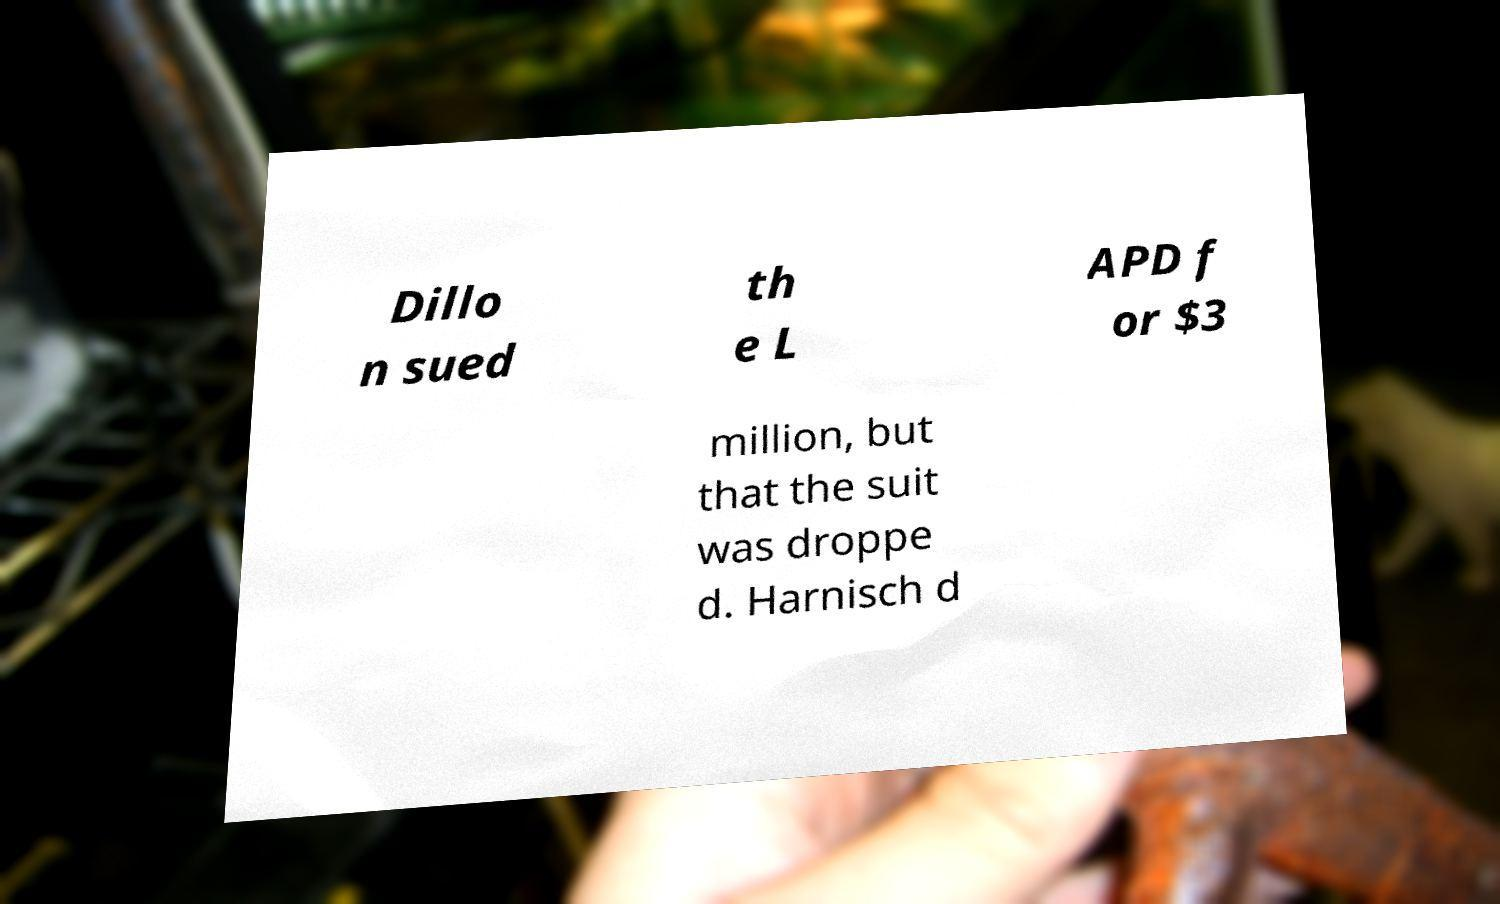Could you extract and type out the text from this image? Dillo n sued th e L APD f or $3 million, but that the suit was droppe d. Harnisch d 